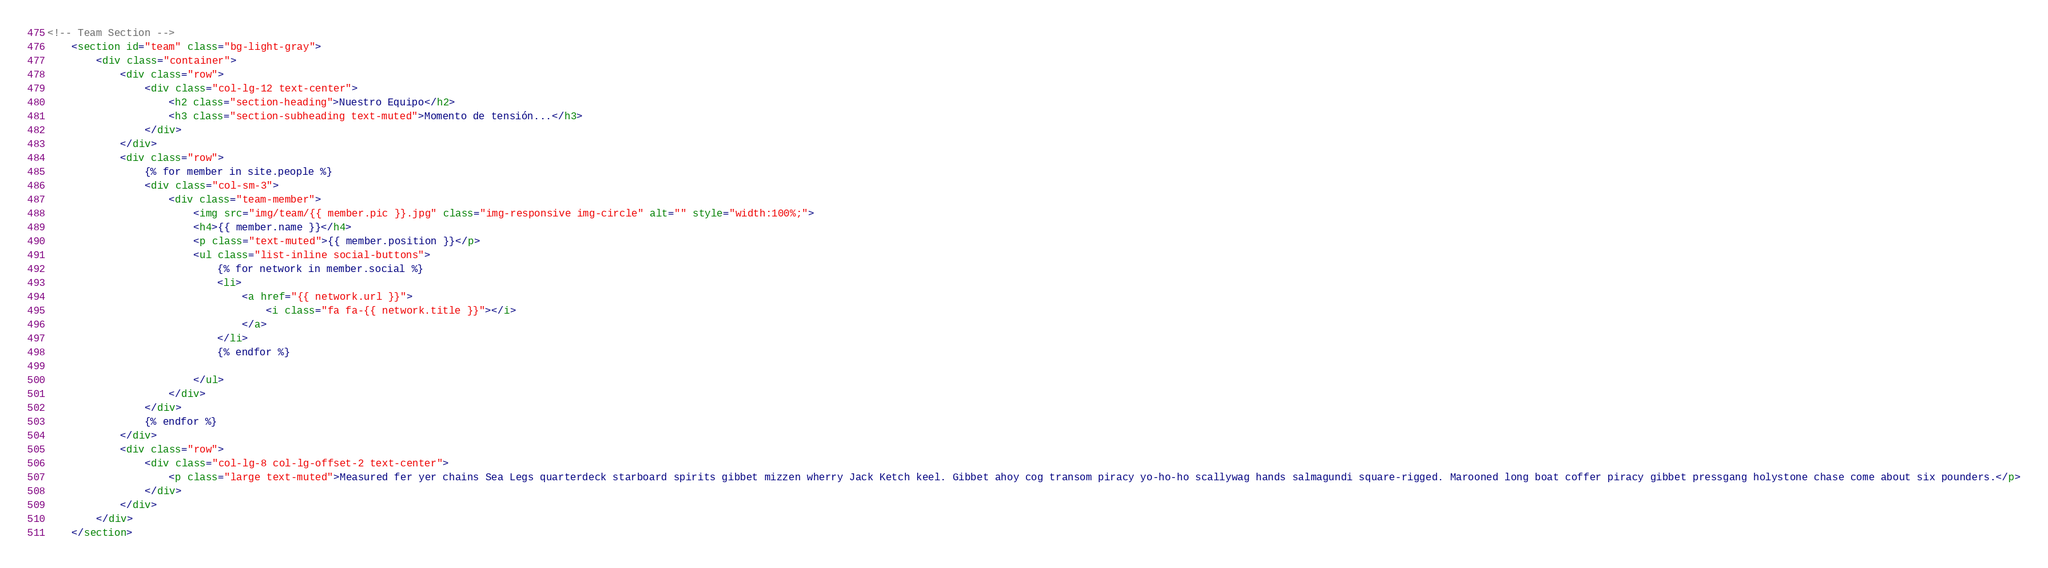<code> <loc_0><loc_0><loc_500><loc_500><_HTML_><!-- Team Section -->
    <section id="team" class="bg-light-gray">
        <div class="container">
            <div class="row">
                <div class="col-lg-12 text-center">
                    <h2 class="section-heading">Nuestro Equipo</h2>
                    <h3 class="section-subheading text-muted">Momento de tensión...</h3>
                </div>
            </div>
            <div class="row">
                {% for member in site.people %}
                <div class="col-sm-3">
                    <div class="team-member">
                        <img src="img/team/{{ member.pic }}.jpg" class="img-responsive img-circle" alt="" style="width:100%;">
                        <h4>{{ member.name }}</h4>
                        <p class="text-muted">{{ member.position }}</p>
                        <ul class="list-inline social-buttons">
                            {% for network in member.social %}
                            <li>
                                <a href="{{ network.url }}">
                                    <i class="fa fa-{{ network.title }}"></i>
                                </a>
                            </li>
                            {% endfor %}

                        </ul>
                    </div>
                </div>
                {% endfor %}
            </div>
            <div class="row">
                <div class="col-lg-8 col-lg-offset-2 text-center">
                    <p class="large text-muted">Measured fer yer chains Sea Legs quarterdeck starboard spirits gibbet mizzen wherry Jack Ketch keel. Gibbet ahoy cog transom piracy yo-ho-ho scallywag hands salmagundi square-rigged. Marooned long boat coffer piracy gibbet pressgang holystone chase come about six pounders.</p>
                </div>
            </div>
        </div>
    </section>
</code> 